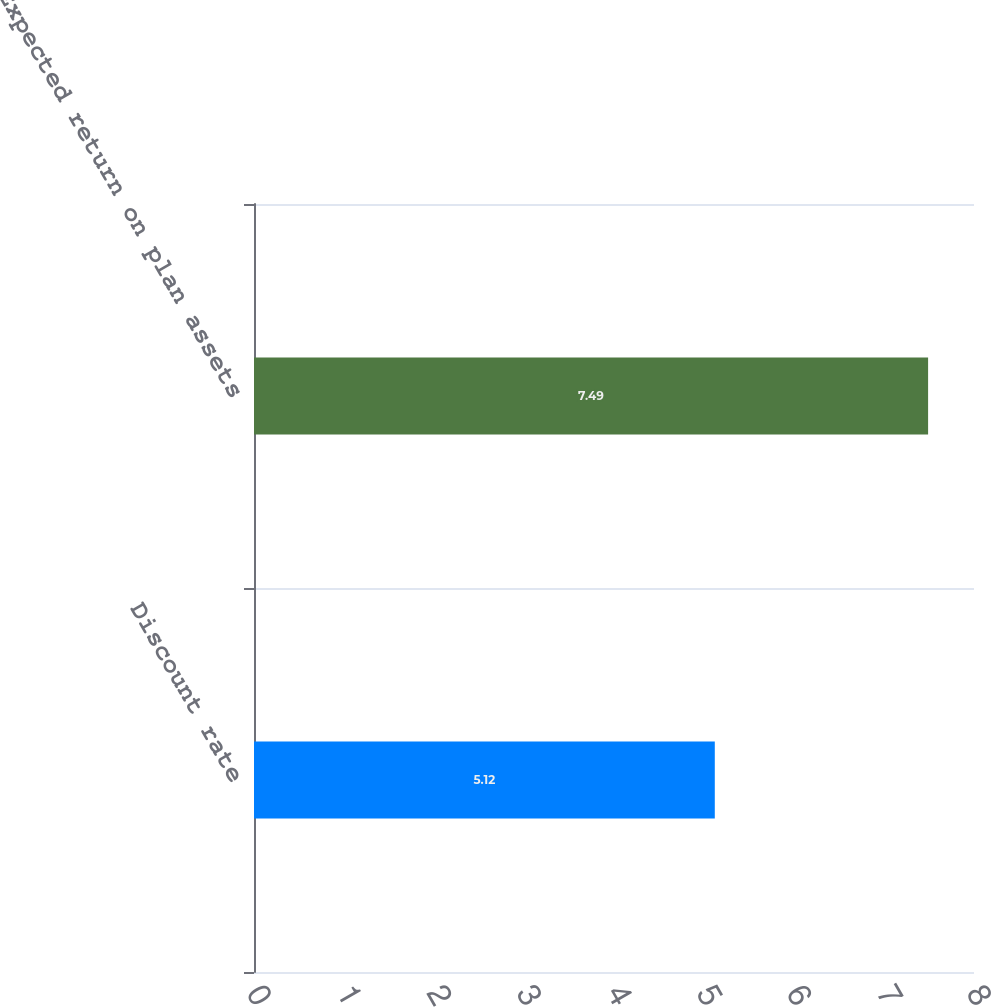<chart> <loc_0><loc_0><loc_500><loc_500><bar_chart><fcel>Discount rate<fcel>Expected return on plan assets<nl><fcel>5.12<fcel>7.49<nl></chart> 